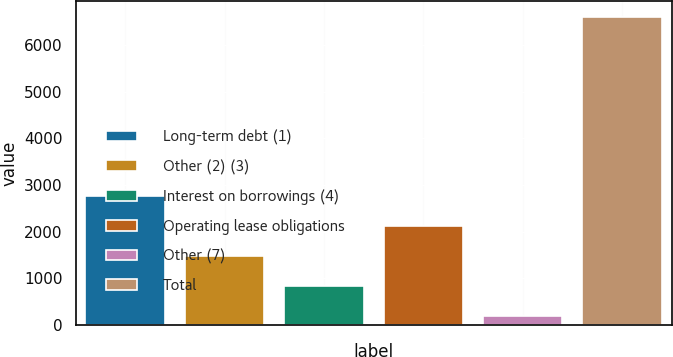<chart> <loc_0><loc_0><loc_500><loc_500><bar_chart><fcel>Long-term debt (1)<fcel>Other (2) (3)<fcel>Interest on borrowings (4)<fcel>Operating lease obligations<fcel>Other (7)<fcel>Total<nl><fcel>2754<fcel>1466<fcel>822<fcel>2110<fcel>178<fcel>6618<nl></chart> 